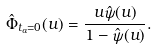Convert formula to latex. <formula><loc_0><loc_0><loc_500><loc_500>\hat { \Phi } _ { t _ { a } = 0 } ( u ) = \frac { u \hat { \psi } ( u ) } { 1 - \hat { \psi } ( u ) } .</formula> 